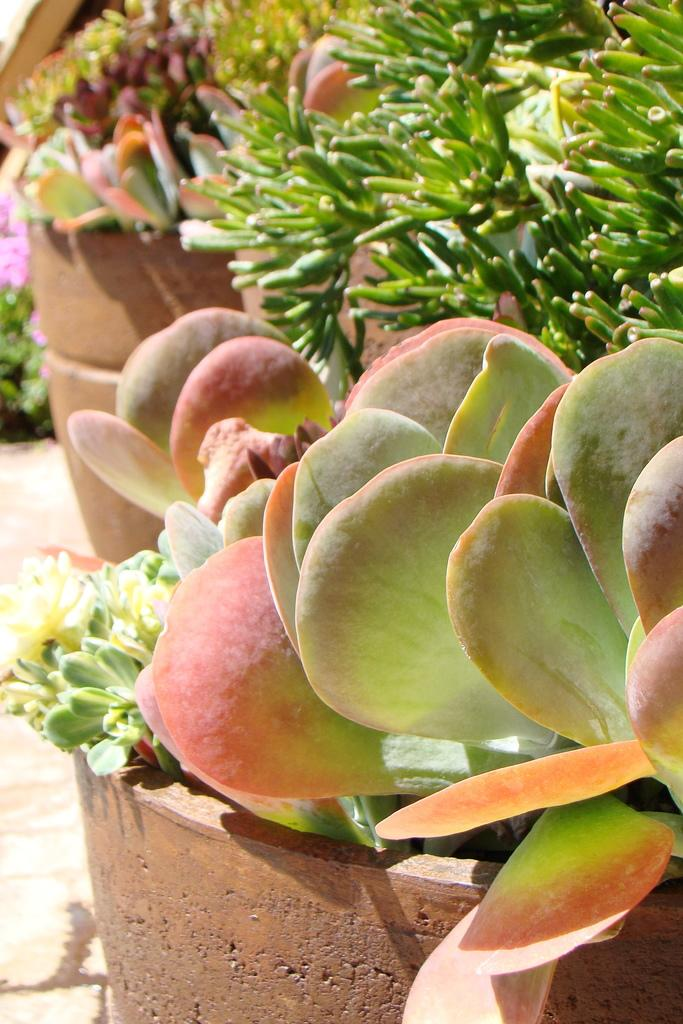What type of plants are in the image? There are potted plants in the image. What type of cave can be seen in the background of the image? There is no cave present in the image; it only features potted plants. What kind of cloth is draped over the potted plants in the image? There is no cloth draped over the potted plants in the image; only the plants are visible. 